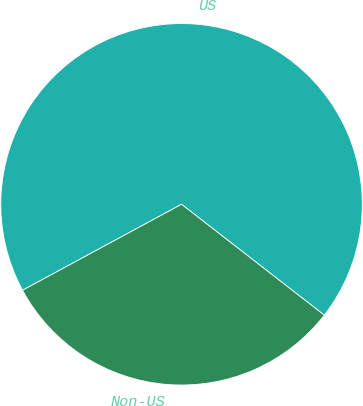Convert chart to OTSL. <chart><loc_0><loc_0><loc_500><loc_500><pie_chart><fcel>US<fcel>Non-US<nl><fcel>68.4%<fcel>31.6%<nl></chart> 